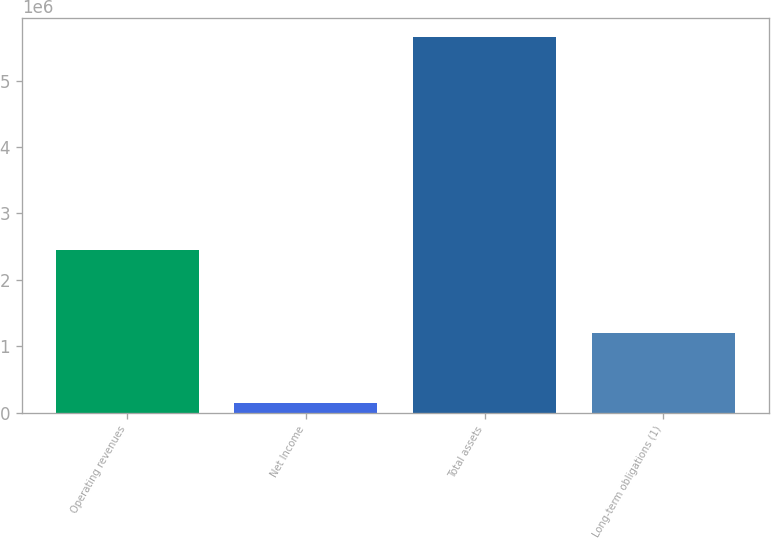Convert chart. <chart><loc_0><loc_0><loc_500><loc_500><bar_chart><fcel>Operating revenues<fcel>Net Income<fcel>Total assets<fcel>Long-term obligations (1)<nl><fcel>2.45126e+06<fcel>137618<fcel>5.65484e+06<fcel>1.19104e+06<nl></chart> 